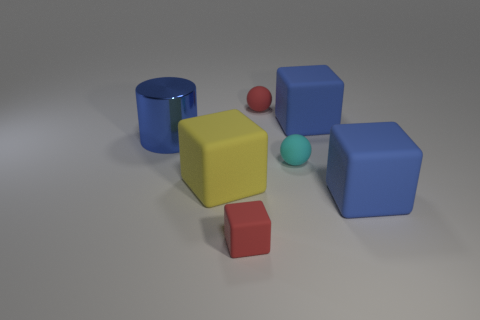There is a rubber object that is the same color as the tiny block; what is its size?
Give a very brief answer. Small. Is the color of the tiny matte object that is behind the large blue shiny object the same as the big cylinder?
Give a very brief answer. No. Is there any other thing that is the same shape as the large yellow object?
Offer a terse response. Yes. There is a matte sphere that is left of the cyan thing; are there any small objects in front of it?
Offer a terse response. Yes. Is the number of large blue metallic objects that are on the right side of the tiny cyan object less than the number of big rubber blocks that are in front of the small red block?
Ensure brevity in your answer.  No. There is a red rubber thing that is on the left side of the red rubber ball that is behind the big blue rubber thing in front of the large yellow thing; how big is it?
Your answer should be compact. Small. Does the red thing that is in front of the red rubber sphere have the same size as the yellow object?
Keep it short and to the point. No. What number of other objects are the same material as the yellow cube?
Your response must be concise. 5. Are there more tiny cyan matte spheres than tiny brown balls?
Give a very brief answer. Yes. What material is the block that is left of the red rubber object in front of the large cube in front of the yellow cube?
Provide a short and direct response. Rubber. 